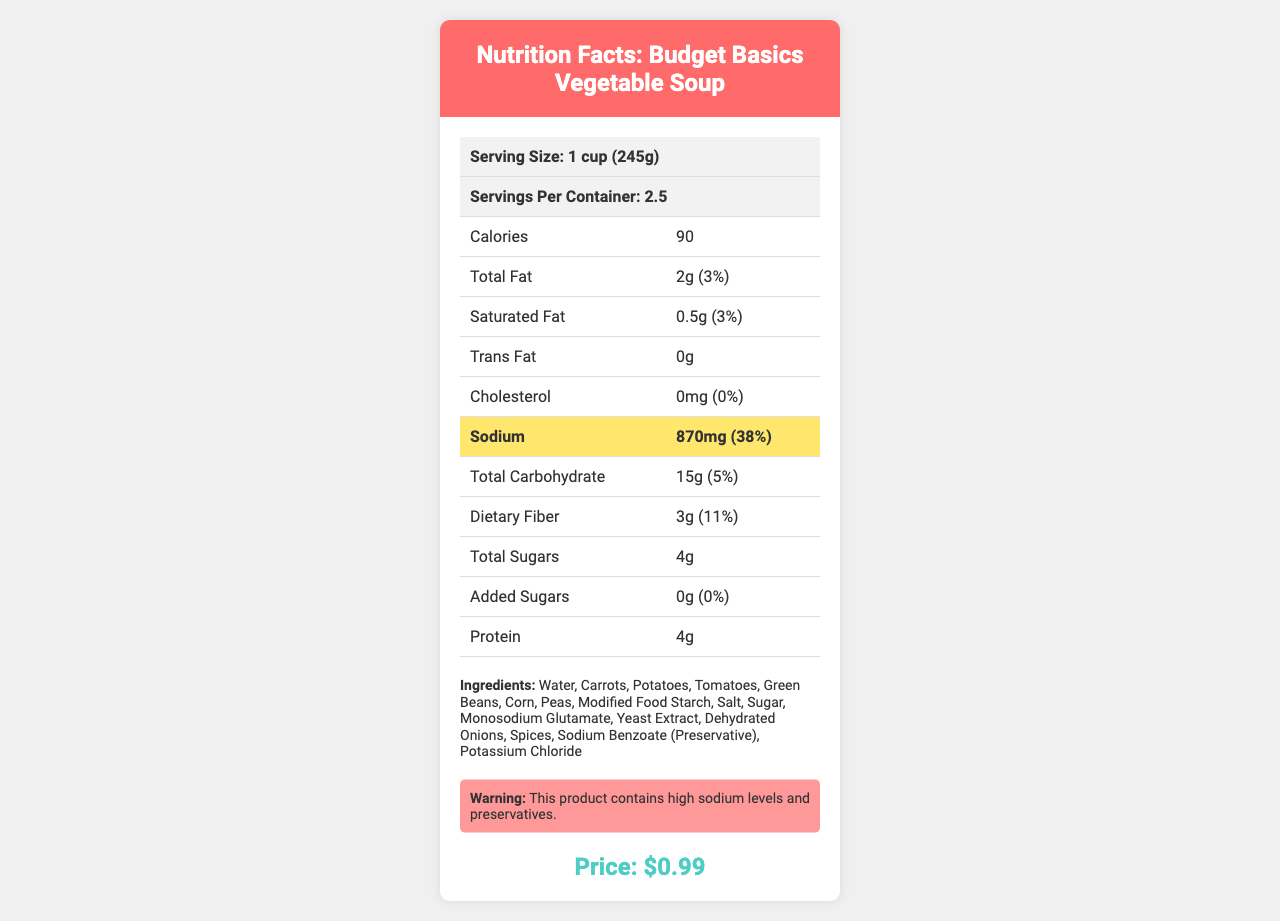what is the serving size? The serving size is stated at the top of the nutrition facts table as "Serving Size: 1 cup (245g)".
Answer: 1 cup (245g) How many servings are in the container? The document lists "Servings Per Container: 2.5" near the top of the table.
Answer: 2.5 What is the total fat percentage of the daily value? The document specifies the total fat as "2g" and the percent daily value as "3%".
Answer: 3% What preservative is mentioned in the ingredients? The ingredients list includes "Sodium Benzoate (Preservative)".
Answer: Sodium Benzoate What is the sodium content per serving? The sodium content per serving is highlighted in the table as "870mg (38%)".
Answer: 870mg what is the total carbohydrate amount per serving? The document shows the total carbohydrate amount as "15g (5%)".
Answer: 15g How many grams of added sugars does the soup contain? The label specifies "Added Sugars: 0g (0%)".
Answer: 0g What is the price of the soup? The document states the price of the soup as "$0.99" in the price section.
Answer: $0.99 How much protein is in one serving of the soup? The nutrition facts list the protein content as "4g".
Answer: 4g How many milligrams of potassium are in one serving? The table shows the potassium content as "230mg (4%)".
Answer: 230mg Is there any soy in this product? The allergen information in the document states "Contains: None".
Answer: No What is the main concern for consumers looking at this nutrition label? The document highlights that the soup contains high sodium levels (38% DV) and preservatives like sodium benzoate.
Answer: High sodium levels and the presence of preservatives Which of the following ingredients are not present in this soup? A. Carrots B. Chicken C. Corn D. Monosodium Glutamate The ingredients list includes Carrots, Corn, and Monosodium Glutamate but not Chicken.
Answer: B What percentage of daily value for saturated fat does one serving contain? A. 2% B. 3% C. 5% D. 10% The document lists the saturated fat percentage as "0.5g (3%)".
Answer: B Does the product contain MSG (Monosodium Glutamate)? The ingredients list includes "Monosodium Glutamate," indicating the presence of MSG.
Answer: Yes Summarize the key nutritional information of Budget Basics Vegetable Soup. This summary covers the essential nutritional facts, ingredients, and pricing for the Budget Basics Vegetable Soup.
Answer: The document provides detailed nutritional information for Budget Basics Vegetable Soup, highlighting a serving size of 1 cup (245g) with 2.5 servings per container. Each serving contains 90 calories, 2g of total fat (3% DV), 0.5g of saturated fat (3% DV), 0g trans fat, 0mg cholesterol, 870mg sodium (38% DV), 15g total carbohydrates (5% DV), 3g dietary fiber (11% DV), 4g total sugars, 0g added sugars, and 4g protein. Additionally, the ingredients include water, vegetables, modified food starch, salt, sugar, and preservatives like monosodium glutamate and sodium benzoate. The product has no allergens and is priced at $0.99. What percentage of the daily value of iron does the product contain? The document lists the iron content as "0.7mg (4%)".
Answer: 4% Who manufactures this soup? The manufacturer is listed at the bottom of the document as "SaveMart Foods, Inc."
Answer: SaveMart Foods, Inc. What is the main idea of the warning section? It states that "This product contains high sodium levels and preservatives."
Answer: The warning section highlights the high sodium levels and the presence of preservatives in the product What is the purpose of the BPA-free can information? The document does not provide details about the purpose or benefits of BPA-free can information.
Answer: Not enough information 